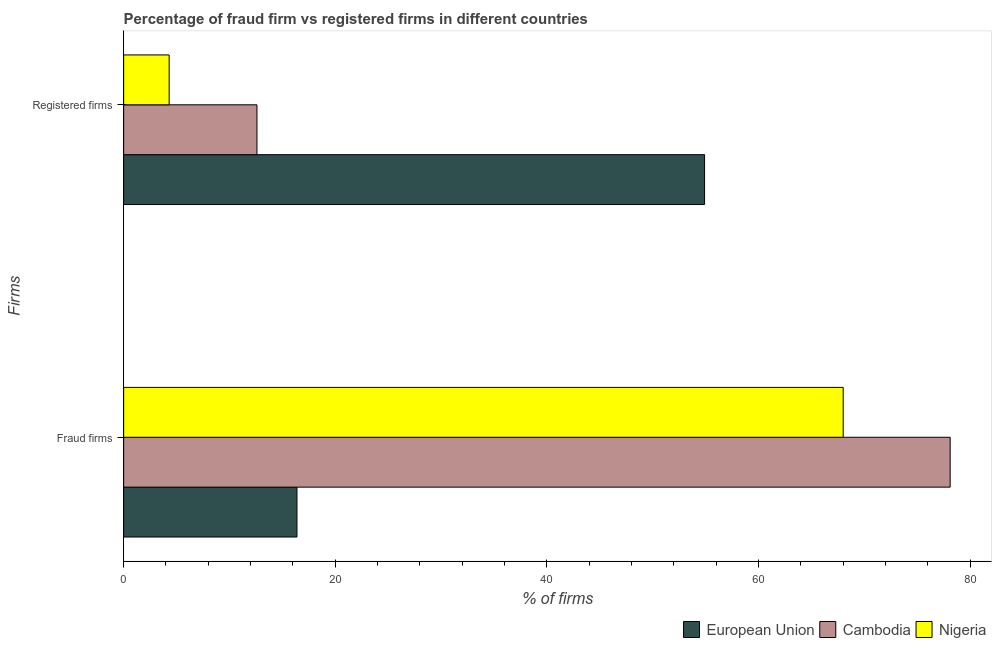How many bars are there on the 1st tick from the bottom?
Your answer should be compact. 3. What is the label of the 2nd group of bars from the top?
Provide a succinct answer. Fraud firms. What is the percentage of registered firms in European Union?
Ensure brevity in your answer.  54.9. Across all countries, what is the maximum percentage of registered firms?
Give a very brief answer. 54.9. Across all countries, what is the minimum percentage of fraud firms?
Provide a succinct answer. 16.38. In which country was the percentage of fraud firms maximum?
Your response must be concise. Cambodia. In which country was the percentage of registered firms minimum?
Offer a very short reply. Nigeria. What is the total percentage of registered firms in the graph?
Make the answer very short. 71.8. What is the difference between the percentage of fraud firms in Cambodia and the percentage of registered firms in Nigeria?
Keep it short and to the point. 73.81. What is the average percentage of fraud firms per country?
Provide a short and direct response. 54.16. What is the difference between the percentage of registered firms and percentage of fraud firms in European Union?
Offer a very short reply. 38.52. In how many countries, is the percentage of registered firms greater than 56 %?
Ensure brevity in your answer.  0. What is the ratio of the percentage of fraud firms in Nigeria to that in European Union?
Make the answer very short. 4.15. Is the percentage of registered firms in European Union less than that in Nigeria?
Give a very brief answer. No. What does the 2nd bar from the top in Fraud firms represents?
Your answer should be compact. Cambodia. What does the 2nd bar from the bottom in Fraud firms represents?
Give a very brief answer. Cambodia. How many bars are there?
Make the answer very short. 6. How many countries are there in the graph?
Make the answer very short. 3. What is the difference between two consecutive major ticks on the X-axis?
Your response must be concise. 20. Does the graph contain any zero values?
Offer a terse response. No. Where does the legend appear in the graph?
Give a very brief answer. Bottom right. How are the legend labels stacked?
Provide a short and direct response. Horizontal. What is the title of the graph?
Ensure brevity in your answer.  Percentage of fraud firm vs registered firms in different countries. What is the label or title of the X-axis?
Offer a terse response. % of firms. What is the label or title of the Y-axis?
Keep it short and to the point. Firms. What is the % of firms in European Union in Fraud firms?
Your answer should be compact. 16.38. What is the % of firms of Cambodia in Fraud firms?
Provide a succinct answer. 78.11. What is the % of firms in Nigeria in Fraud firms?
Make the answer very short. 68. What is the % of firms of European Union in Registered firms?
Provide a succinct answer. 54.9. What is the % of firms of Cambodia in Registered firms?
Offer a terse response. 12.6. What is the % of firms in Nigeria in Registered firms?
Provide a short and direct response. 4.3. Across all Firms, what is the maximum % of firms of European Union?
Ensure brevity in your answer.  54.9. Across all Firms, what is the maximum % of firms in Cambodia?
Your answer should be very brief. 78.11. Across all Firms, what is the minimum % of firms in European Union?
Your answer should be compact. 16.38. Across all Firms, what is the minimum % of firms of Nigeria?
Offer a very short reply. 4.3. What is the total % of firms of European Union in the graph?
Keep it short and to the point. 71.28. What is the total % of firms of Cambodia in the graph?
Make the answer very short. 90.71. What is the total % of firms in Nigeria in the graph?
Give a very brief answer. 72.3. What is the difference between the % of firms in European Union in Fraud firms and that in Registered firms?
Your response must be concise. -38.52. What is the difference between the % of firms of Cambodia in Fraud firms and that in Registered firms?
Your answer should be compact. 65.51. What is the difference between the % of firms of Nigeria in Fraud firms and that in Registered firms?
Your answer should be compact. 63.7. What is the difference between the % of firms of European Union in Fraud firms and the % of firms of Cambodia in Registered firms?
Make the answer very short. 3.78. What is the difference between the % of firms in European Union in Fraud firms and the % of firms in Nigeria in Registered firms?
Provide a short and direct response. 12.08. What is the difference between the % of firms in Cambodia in Fraud firms and the % of firms in Nigeria in Registered firms?
Make the answer very short. 73.81. What is the average % of firms in European Union per Firms?
Ensure brevity in your answer.  35.64. What is the average % of firms in Cambodia per Firms?
Keep it short and to the point. 45.35. What is the average % of firms in Nigeria per Firms?
Your answer should be compact. 36.15. What is the difference between the % of firms in European Union and % of firms in Cambodia in Fraud firms?
Provide a short and direct response. -61.73. What is the difference between the % of firms in European Union and % of firms in Nigeria in Fraud firms?
Make the answer very short. -51.62. What is the difference between the % of firms of Cambodia and % of firms of Nigeria in Fraud firms?
Make the answer very short. 10.11. What is the difference between the % of firms in European Union and % of firms in Cambodia in Registered firms?
Offer a very short reply. 42.3. What is the difference between the % of firms of European Union and % of firms of Nigeria in Registered firms?
Ensure brevity in your answer.  50.6. What is the difference between the % of firms in Cambodia and % of firms in Nigeria in Registered firms?
Ensure brevity in your answer.  8.3. What is the ratio of the % of firms in European Union in Fraud firms to that in Registered firms?
Keep it short and to the point. 0.3. What is the ratio of the % of firms in Cambodia in Fraud firms to that in Registered firms?
Ensure brevity in your answer.  6.2. What is the ratio of the % of firms of Nigeria in Fraud firms to that in Registered firms?
Provide a short and direct response. 15.81. What is the difference between the highest and the second highest % of firms of European Union?
Ensure brevity in your answer.  38.52. What is the difference between the highest and the second highest % of firms in Cambodia?
Keep it short and to the point. 65.51. What is the difference between the highest and the second highest % of firms of Nigeria?
Make the answer very short. 63.7. What is the difference between the highest and the lowest % of firms of European Union?
Make the answer very short. 38.52. What is the difference between the highest and the lowest % of firms of Cambodia?
Ensure brevity in your answer.  65.51. What is the difference between the highest and the lowest % of firms of Nigeria?
Your answer should be very brief. 63.7. 